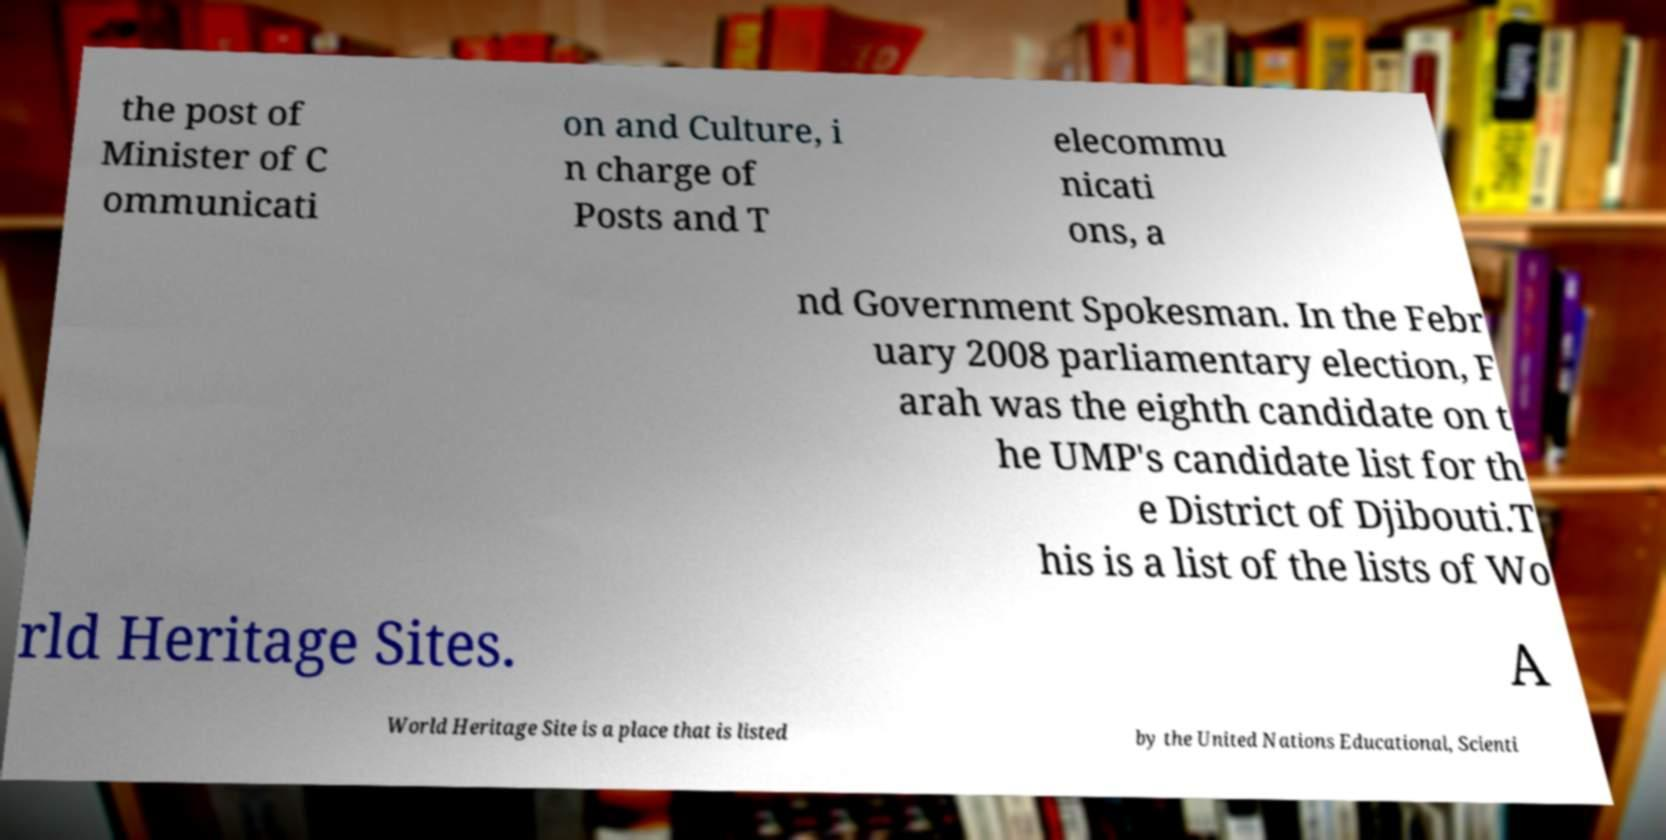Can you read and provide the text displayed in the image?This photo seems to have some interesting text. Can you extract and type it out for me? the post of Minister of C ommunicati on and Culture, i n charge of Posts and T elecommu nicati ons, a nd Government Spokesman. In the Febr uary 2008 parliamentary election, F arah was the eighth candidate on t he UMP's candidate list for th e District of Djibouti.T his is a list of the lists of Wo rld Heritage Sites. A World Heritage Site is a place that is listed by the United Nations Educational, Scienti 